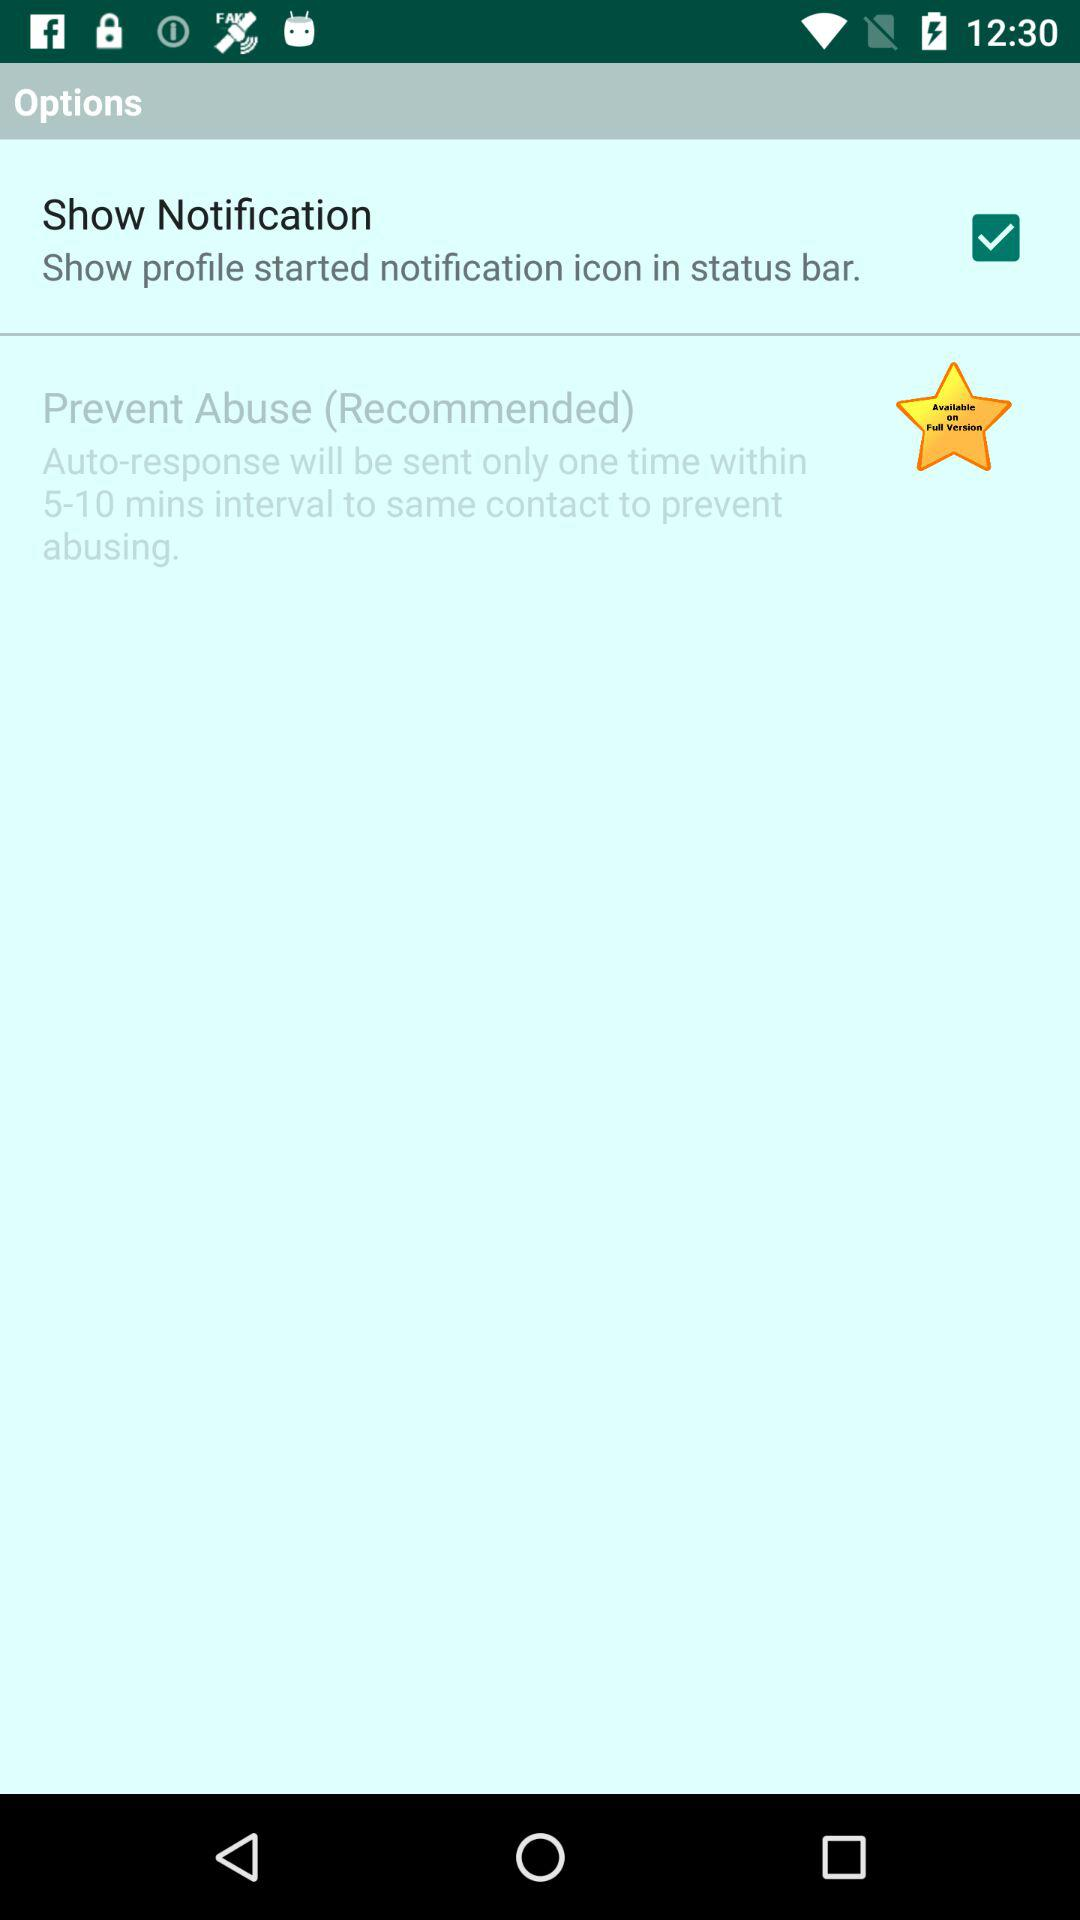In what time interval will the auto-response be sent to prevent abuse? The auto-response will be sent within 5 to 10 minutes to prevent abuse. 